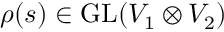Convert formula to latex. <formula><loc_0><loc_0><loc_500><loc_500>\rho ( s ) \in { G L } ( V _ { 1 } \otimes V _ { 2 } )</formula> 